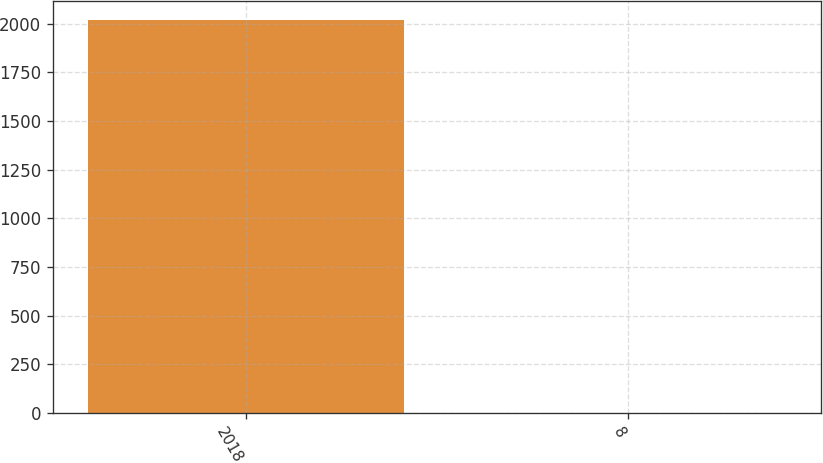<chart> <loc_0><loc_0><loc_500><loc_500><bar_chart><fcel>2018<fcel>8<nl><fcel>2018<fcel>1<nl></chart> 